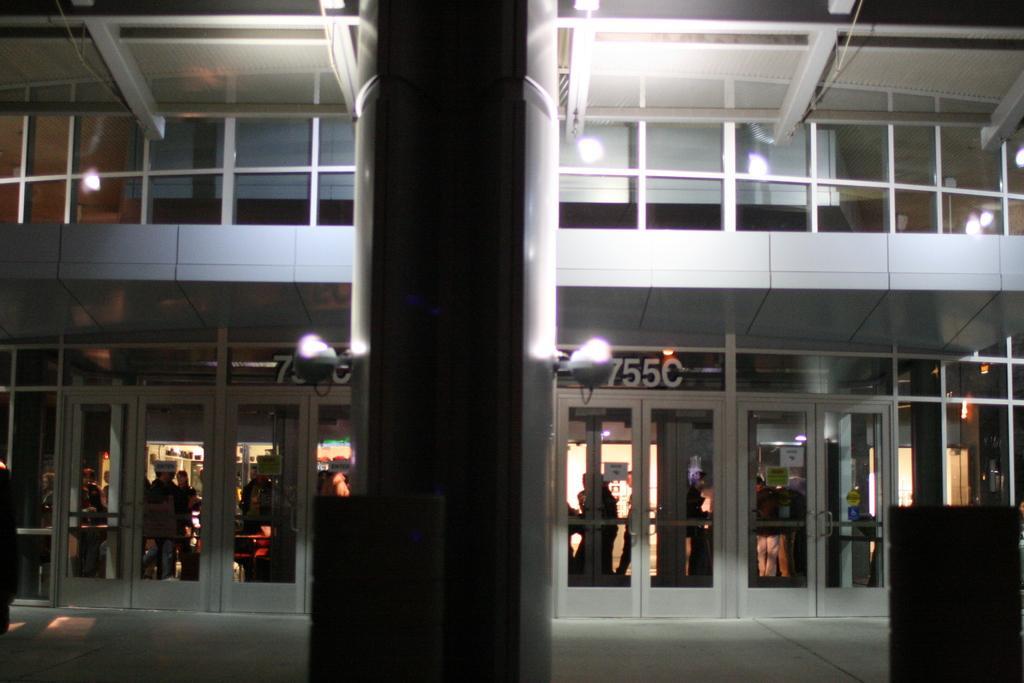In one or two sentences, can you explain what this image depicts? In this image there is a building, there are lights and group of people. 